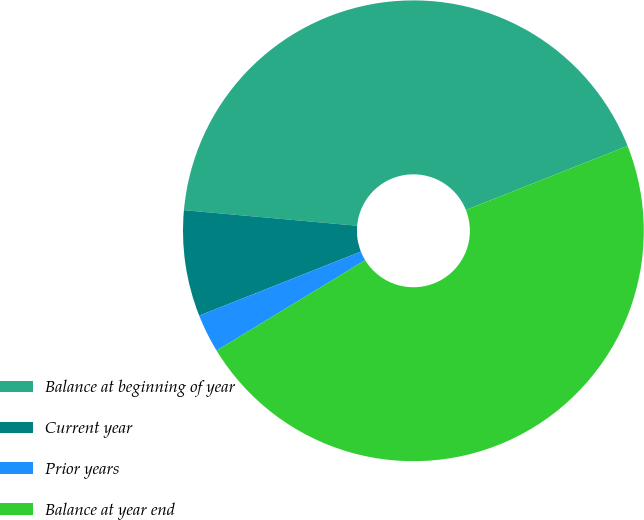<chart> <loc_0><loc_0><loc_500><loc_500><pie_chart><fcel>Balance at beginning of year<fcel>Current year<fcel>Prior years<fcel>Balance at year end<nl><fcel>42.57%<fcel>7.43%<fcel>2.7%<fcel>47.3%<nl></chart> 